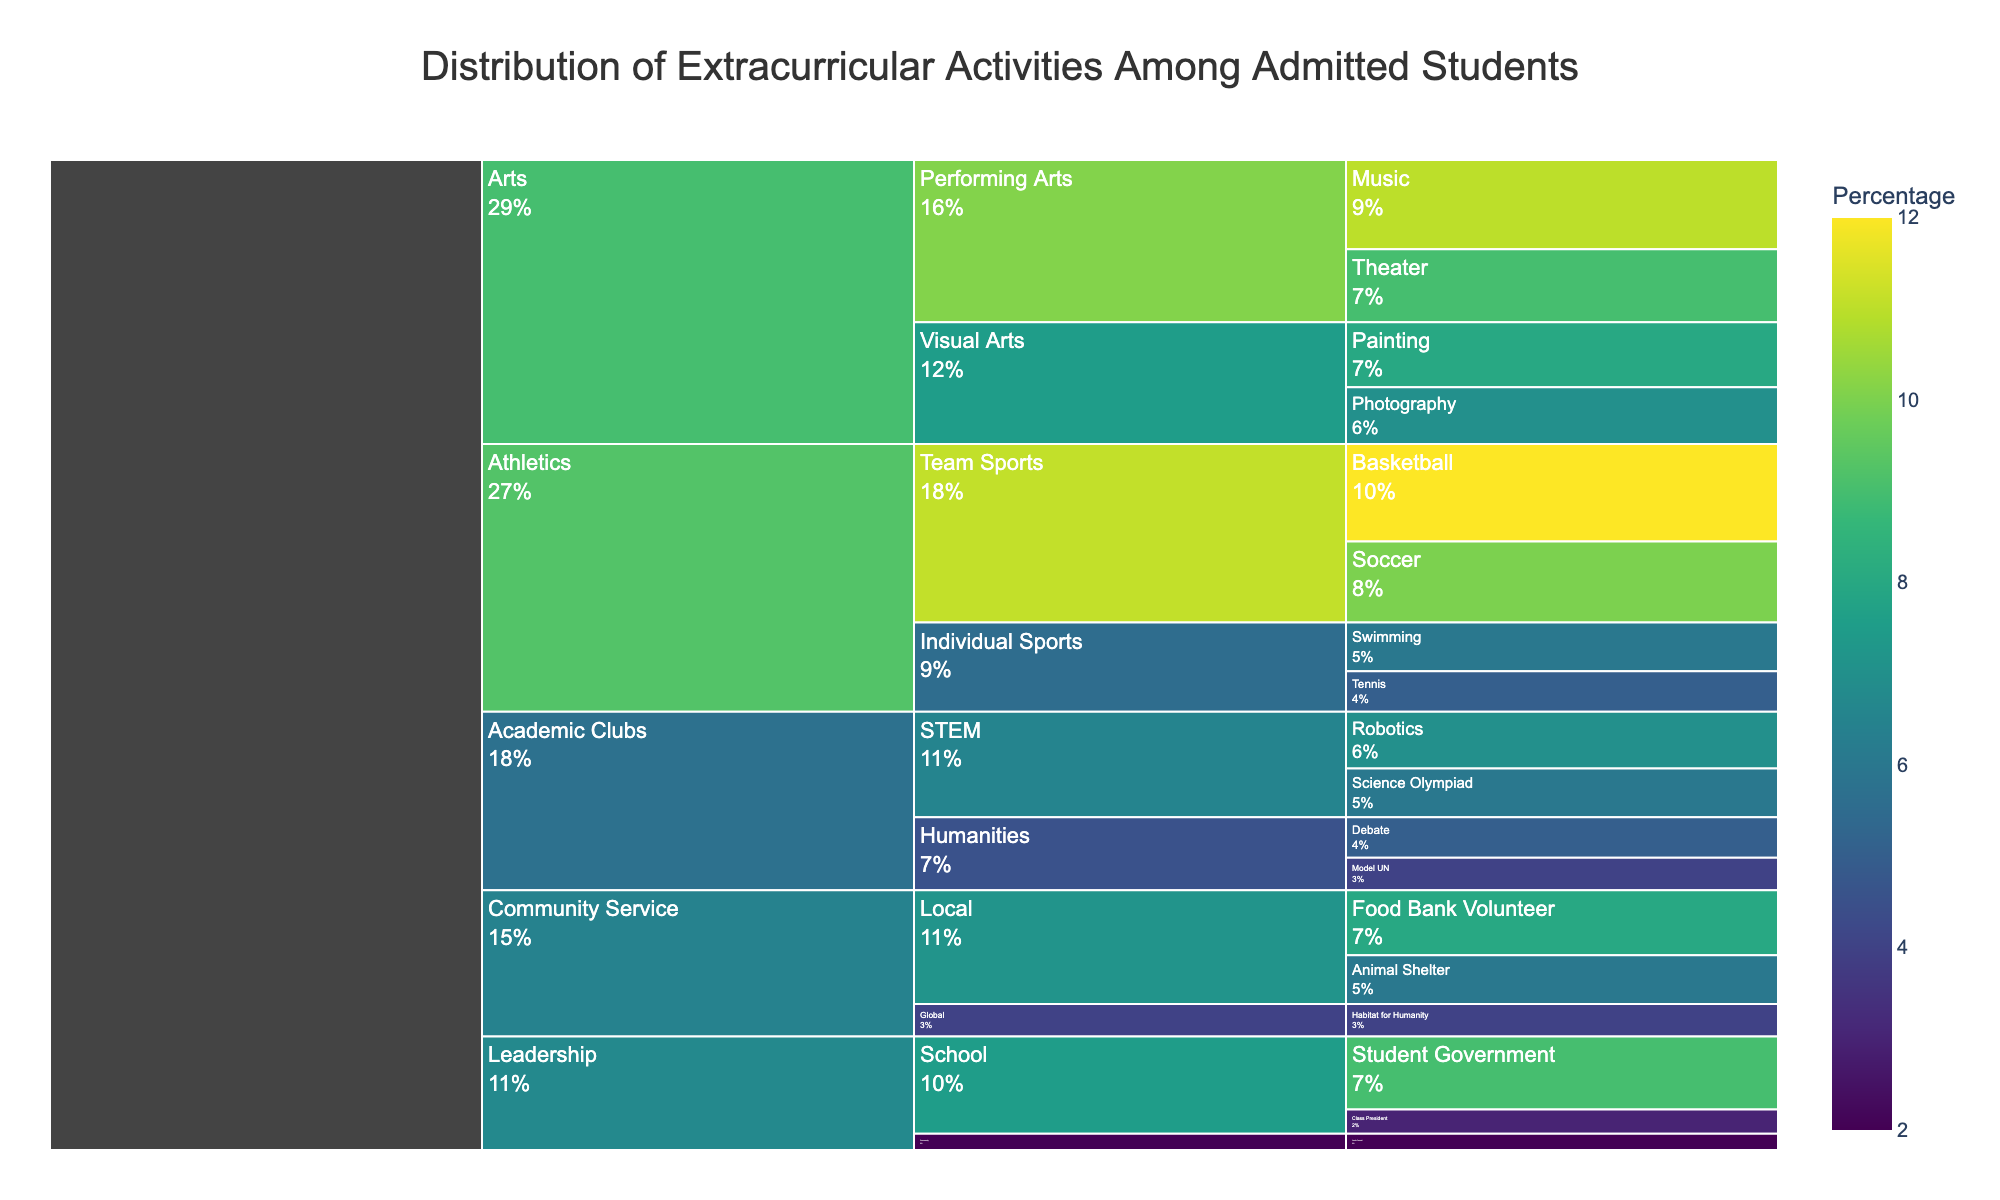What is the title of the figure? The title of an icicle chart is typically displayed at the top. From the provided information, the title is "Distribution of Extracurricular Activities Among Admitted Students".
Answer: Distribution of Extracurricular Activities Among Admitted Students Which activity in the 'Athletics' category has the highest percentage? The 'Athletics' category has subcategories like 'Team Sports' and 'Individual Sports'. Within 'Team Sports', Basketball is 12% which is higher than Soccer's 10%. Tennis and Swimming in 'Individual Sports' are also lower at 5% and 6% respectively, making Basketball the highest.
Answer: Basketball What's the combined percentage of students involved in 'Performing Arts'? The 'Performing Arts' subcategory under 'Arts' includes 'Theater' with 9% and 'Music' with 11%. The combined percentage is calculated by adding these two values: 9% + 11% = 20%.
Answer: 20% Which category has more students: 'Community Service' or 'Leadership'? We need to sum the percentages of all activities within each category. For 'Community Service': Food Bank Volunteer (8%), Animal Shelter (6%), Habitat for Humanity (4%) which totals 8% + 6% + 4% = 18%. For 'Leadership': Student Government (9%), Class President (3%), Youth Council (2%) totaling 9% + 3% + 2% = 14%. 'Community Service' has more.
Answer: Community Service What’s the difference in percentage between students involved in 'Visual Arts' and 'Individual Sports'? Sum the percentages for 'Visual Arts' (Painting 8% + Photography 7%) = 15%. Sum the percentages for 'Individual Sports' (Tennis 5% + Swimming 6%) = 11%. The difference is 15% - 11% = 4%.
Answer: 4% What is the total percentage of students involved in 'STEM' activities within 'Academic Clubs'? The 'STEM' subcategory includes 'Robotics' at 7% and 'Science Olympiad' at 6%. Adding these two percentages yields a total of 7% + 6% = 13%.
Answer: 13% Which activity has the lowest percentage and to which category does it belong? Reviewing all percentages, the lowest percentage is 2%, and the activity is 'Youth Council' under the 'Leadership' category.
Answer: Youth Council in Leadership How many activities fall under the category 'Arts'? The 'Arts' category has two subcategories: 'Visual Arts' with 'Painting' and 'Photography', and 'Performing Arts' with 'Theater' and 'Music'. Totaling these gives 2 (Visual) + 2 (Performing) = 4 activities.
Answer: 4 Which subcategory has a higher percentage, 'Team Sports' or 'Performing Arts'? Summing percentages for 'Team Sports' (Basketball 12% + Soccer 10%) = 22%, and for 'Performing Arts' (Theater 9% + Music 11%) = 20%. Comparing these, 'Team Sports' (22%) is higher than 'Performing Arts' (20%).
Answer: Team Sports 